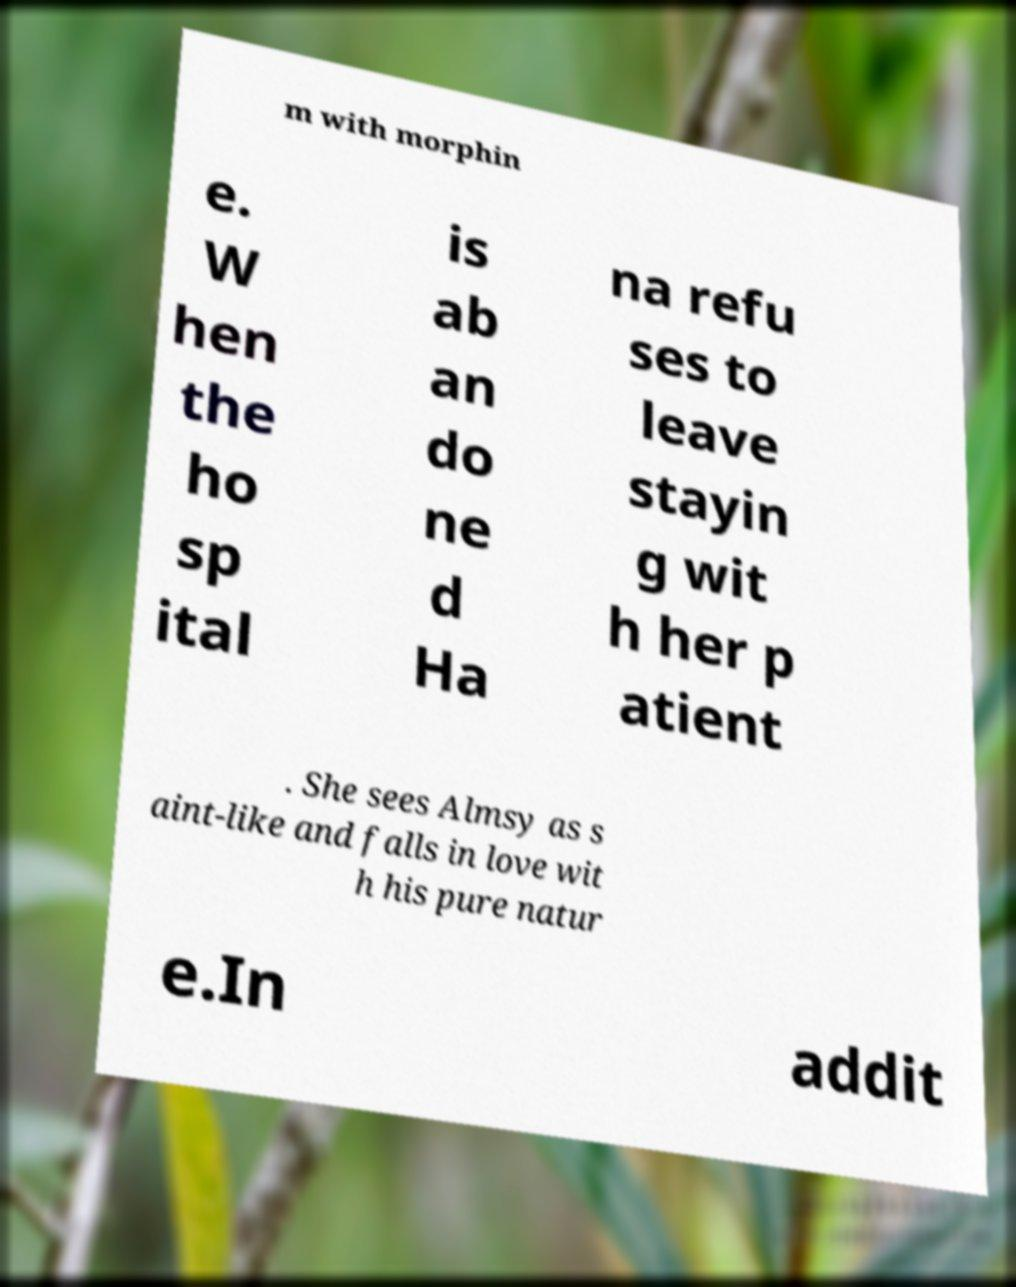Can you read and provide the text displayed in the image?This photo seems to have some interesting text. Can you extract and type it out for me? m with morphin e. W hen the ho sp ital is ab an do ne d Ha na refu ses to leave stayin g wit h her p atient . She sees Almsy as s aint-like and falls in love wit h his pure natur e.In addit 